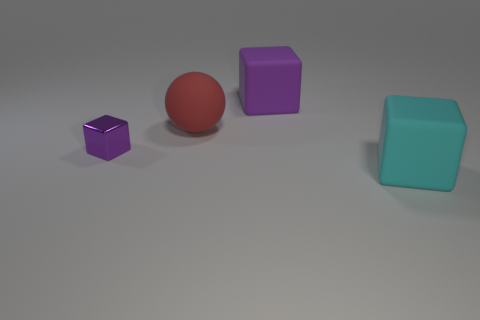Is there a purple thing made of the same material as the red thing?
Provide a short and direct response. Yes. There is a large object that is on the left side of the purple block behind the red object; what is its material?
Give a very brief answer. Rubber. There is a rubber object that is right of the purple rubber object; what size is it?
Your answer should be very brief. Large. There is a shiny cube; does it have the same color as the large cube that is behind the cyan block?
Make the answer very short. Yes. Is there another block of the same color as the metallic block?
Your answer should be compact. Yes. Is the red thing made of the same material as the large cube that is left of the cyan cube?
Give a very brief answer. Yes. What number of big objects are either purple blocks or purple balls?
Ensure brevity in your answer.  1. What material is the big object that is the same color as the small thing?
Your answer should be compact. Rubber. Is the number of rubber balls less than the number of things?
Your answer should be compact. Yes. Do the block to the left of the sphere and the purple cube that is right of the tiny purple metal thing have the same size?
Give a very brief answer. No. 